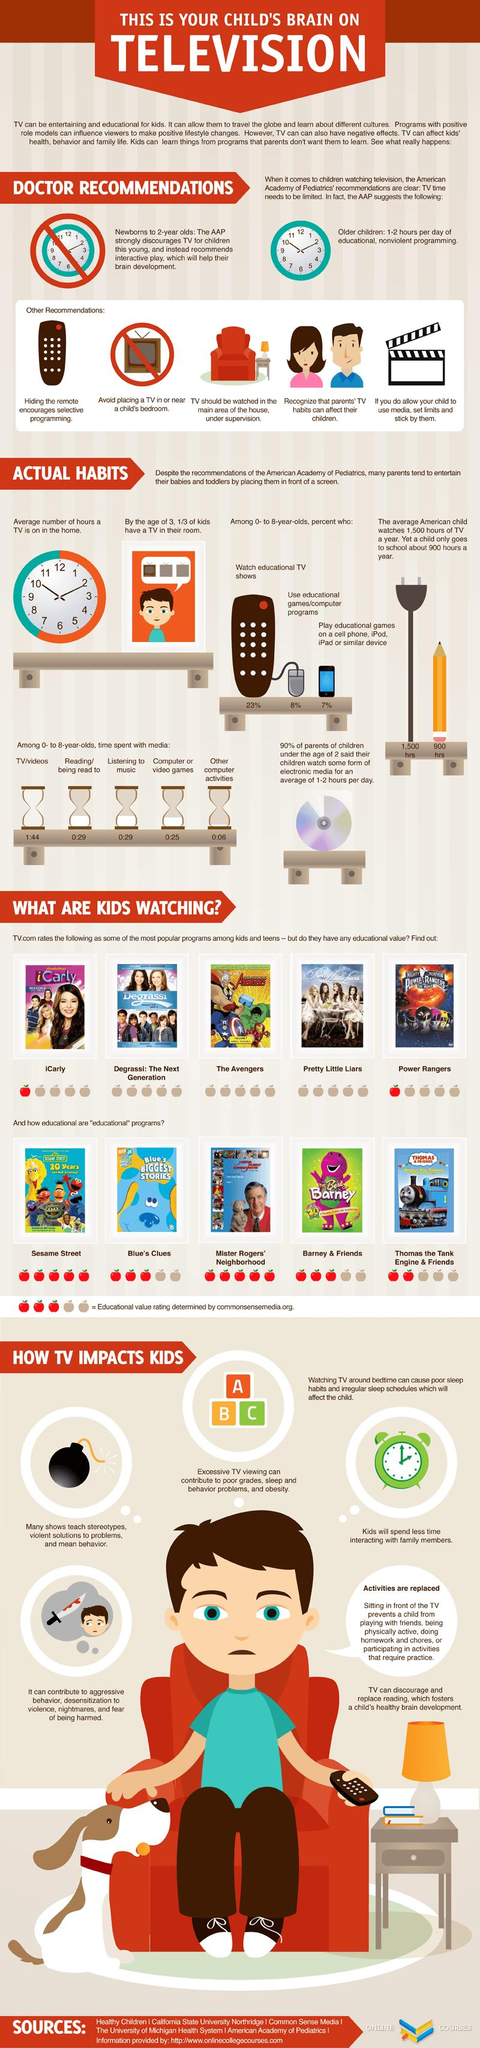Specify some key components in this picture. According to recent data in America, only 8% of children aged 0-8 years use educational games or computer programs. According to a recent survey, approximately 23% of children aged 0-8 years in America watch educational TV shows. 